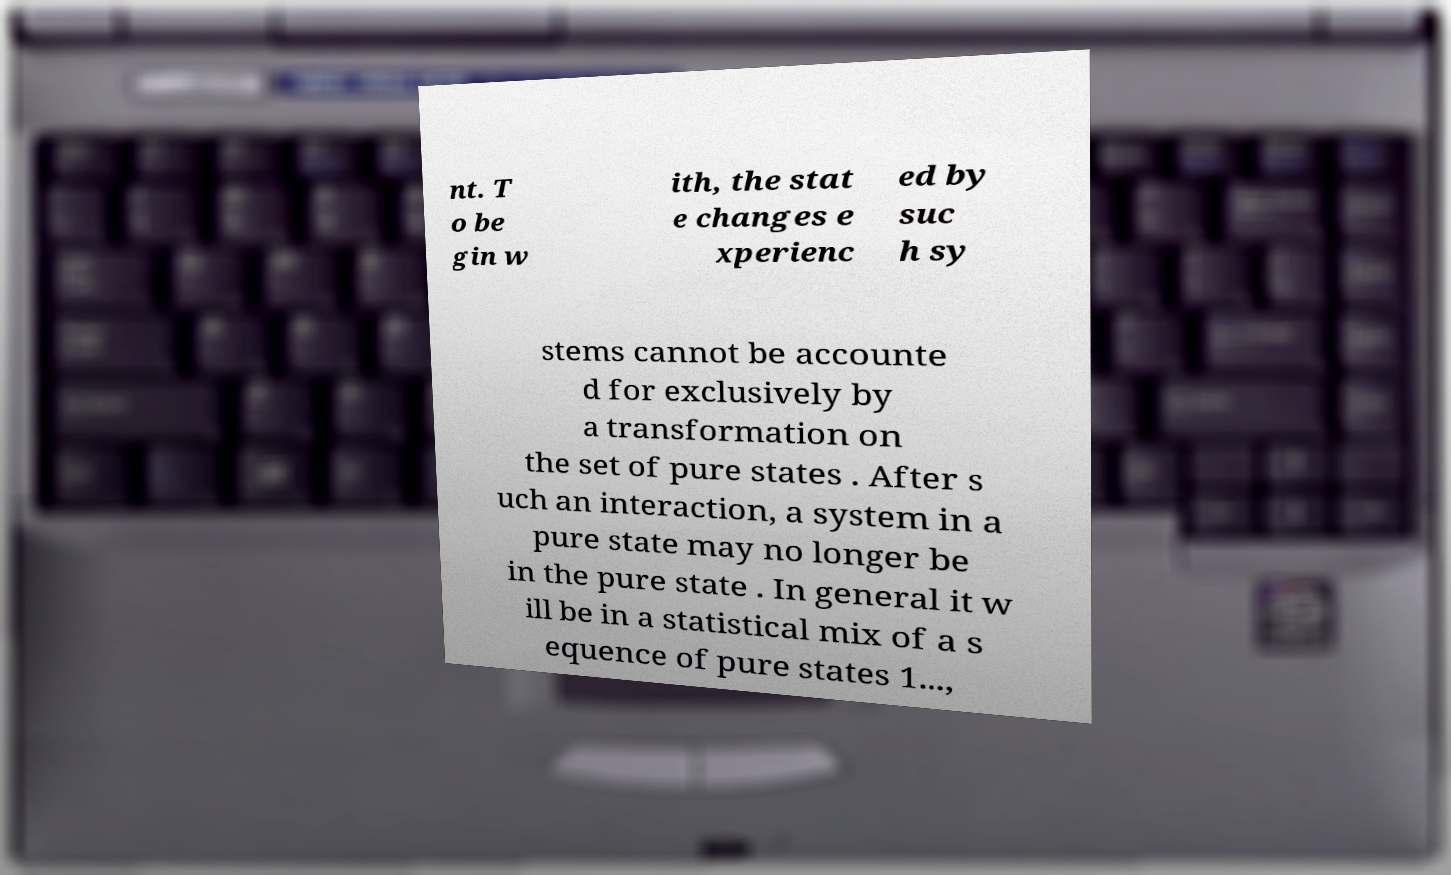Please read and relay the text visible in this image. What does it say? nt. T o be gin w ith, the stat e changes e xperienc ed by suc h sy stems cannot be accounte d for exclusively by a transformation on the set of pure states . After s uch an interaction, a system in a pure state may no longer be in the pure state . In general it w ill be in a statistical mix of a s equence of pure states 1..., 